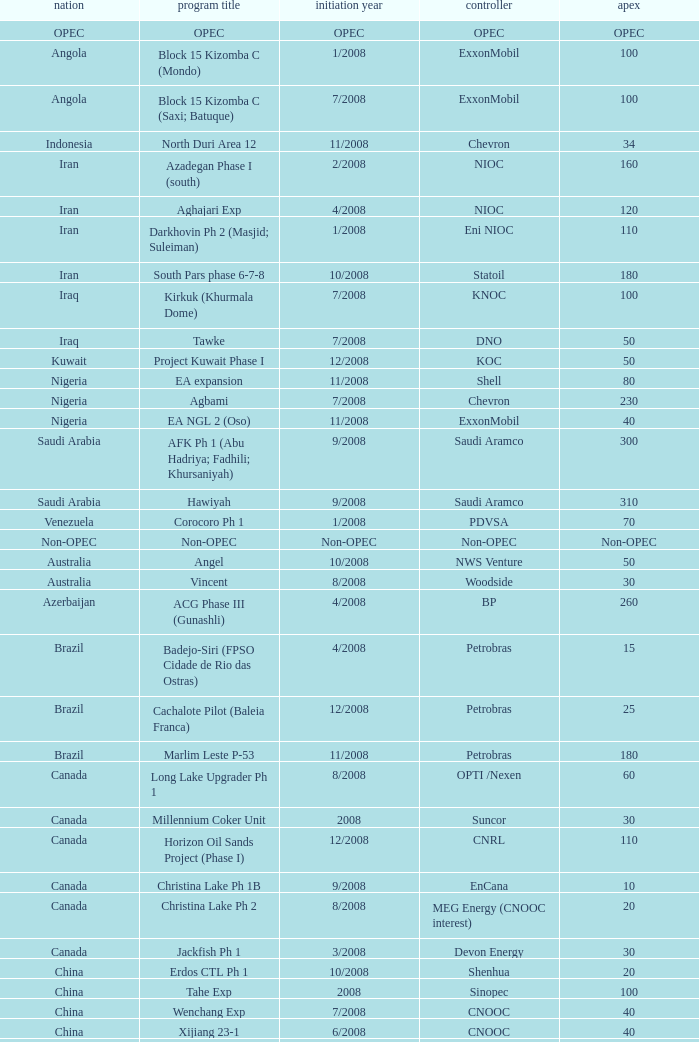What is the Peak with a Project Name that is talakan ph 1? 60.0. 